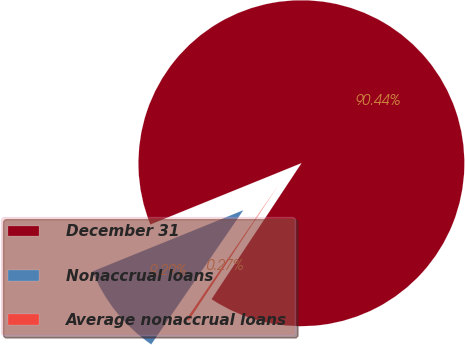<chart> <loc_0><loc_0><loc_500><loc_500><pie_chart><fcel>December 31<fcel>Nonaccrual loans<fcel>Average nonaccrual loans<nl><fcel>90.44%<fcel>9.29%<fcel>0.27%<nl></chart> 